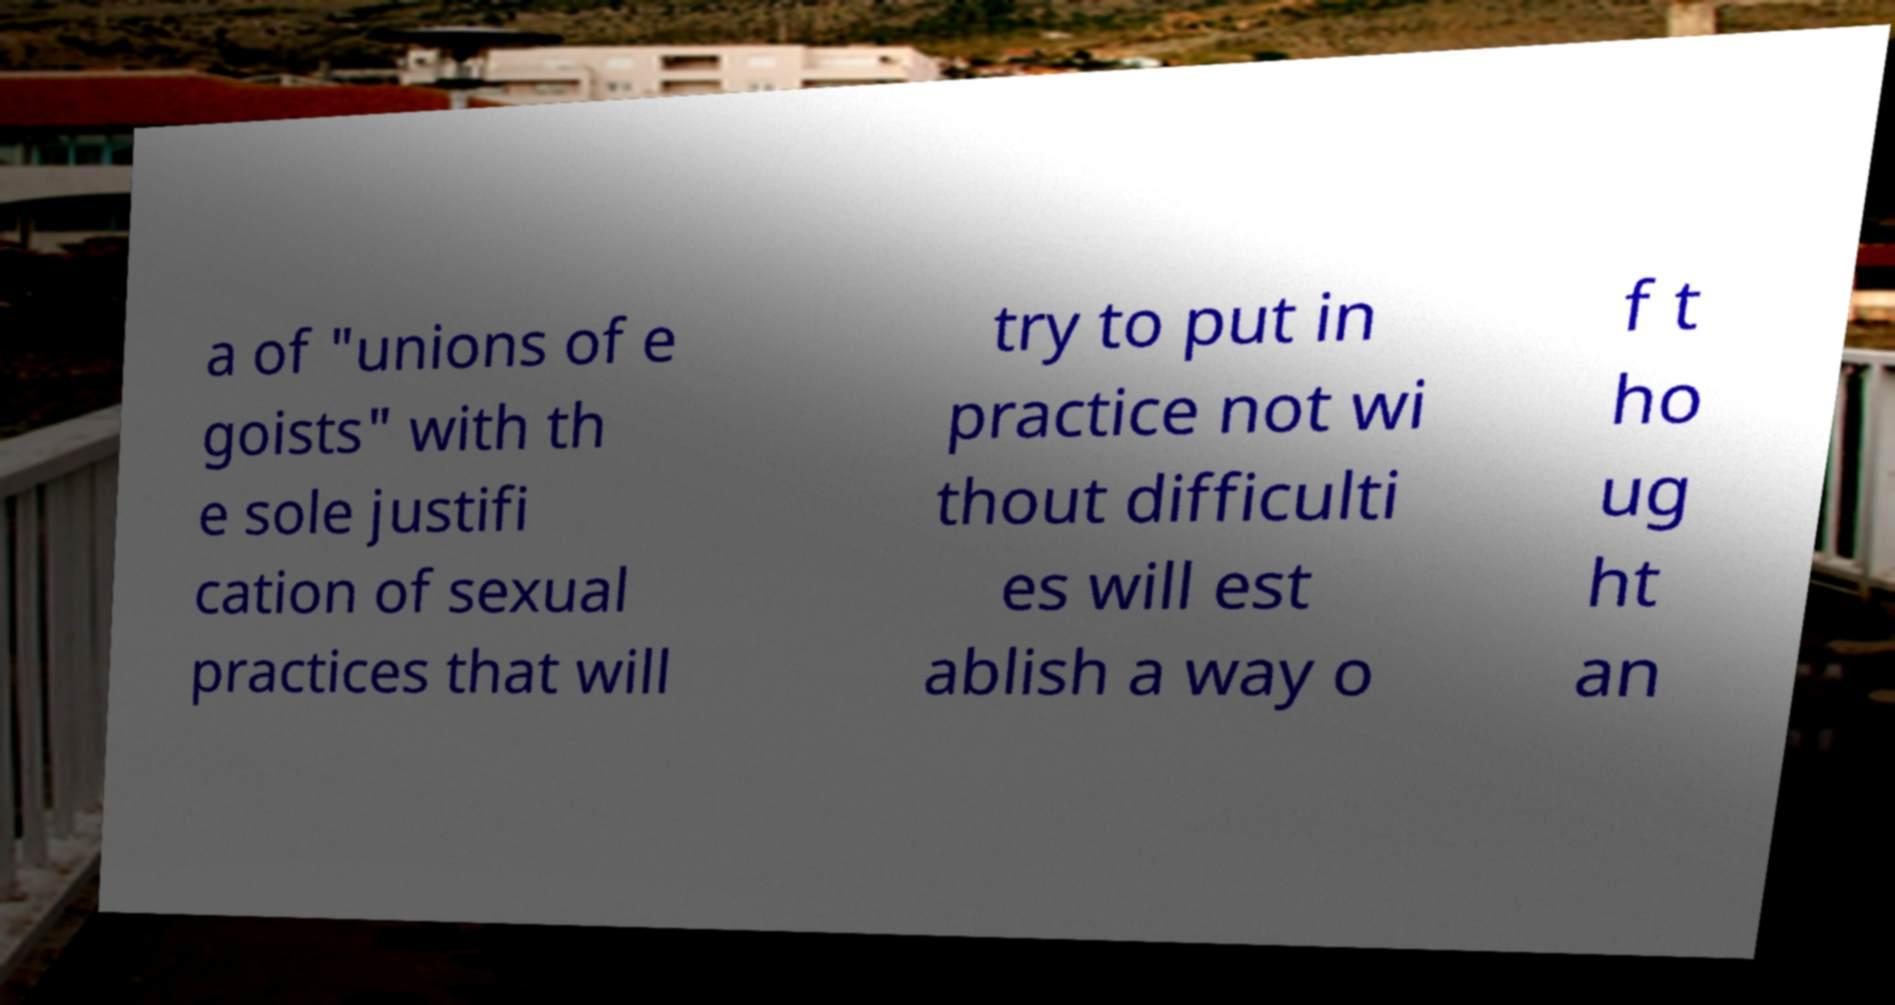Please identify and transcribe the text found in this image. a of "unions of e goists" with th e sole justifi cation of sexual practices that will try to put in practice not wi thout difficulti es will est ablish a way o f t ho ug ht an 